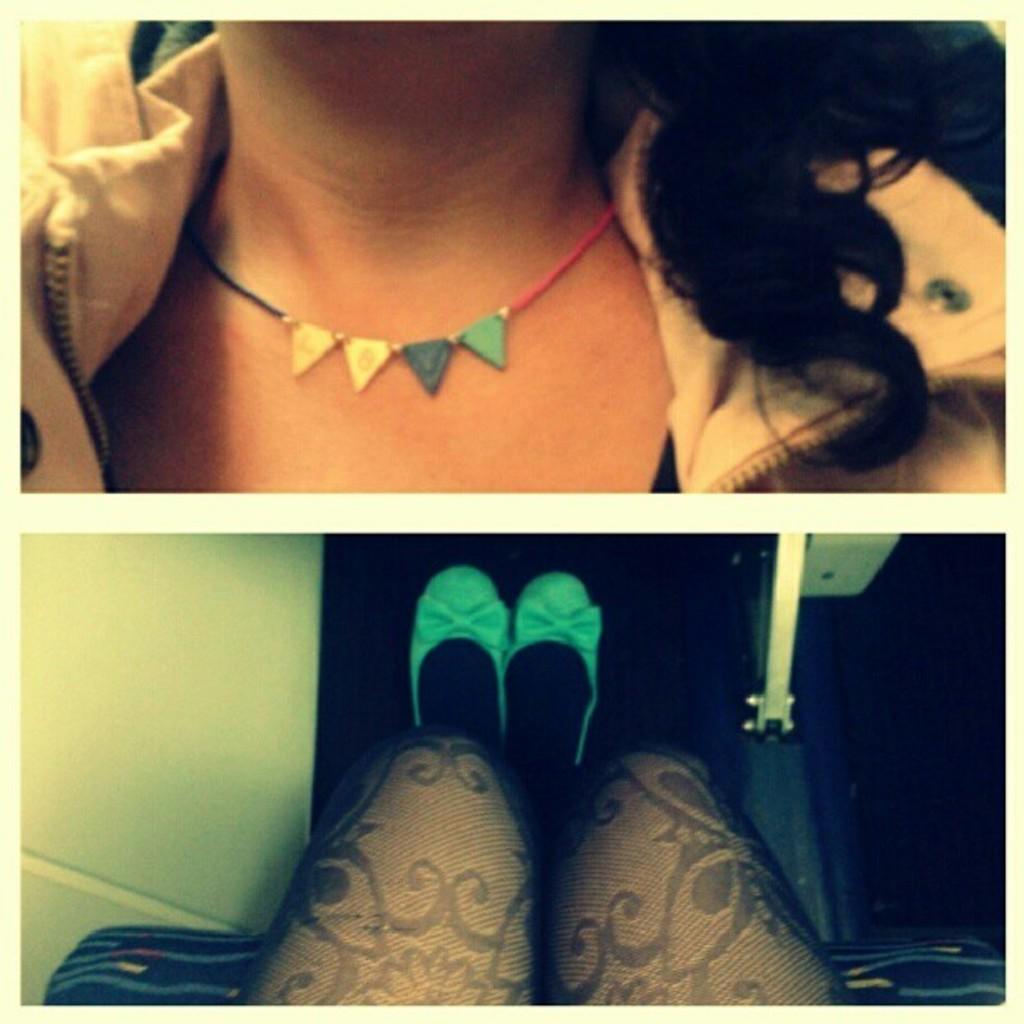How would you summarize this image in a sentence or two? This image is a collage of two images. In the bottom image there are two legs of a person and there is a wall. At the top of the image there is a woman with a neck chain and a jacket. 